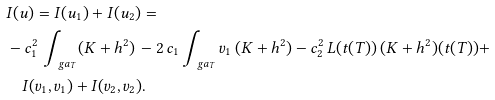Convert formula to latex. <formula><loc_0><loc_0><loc_500><loc_500>& I ( u ) = I ( u _ { 1 } ) + I ( u _ { 2 } ) = \\ & - c _ { 1 } ^ { 2 } \, \int _ { \ g a _ { T } } ( K + h ^ { 2 } ) \, - 2 \, c _ { 1 } \int _ { \ g a _ { T } } v _ { 1 } \, ( K + h ^ { 2 } ) - c _ { 2 } ^ { 2 } \, L ( t ( T ) ) \, ( K + h ^ { 2 } ) ( t ( T ) ) + \\ & \quad I ( v _ { 1 } , v _ { 1 } ) + I ( v _ { 2 } , v _ { 2 } ) .</formula> 